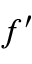Convert formula to latex. <formula><loc_0><loc_0><loc_500><loc_500>f ^ { \prime }</formula> 